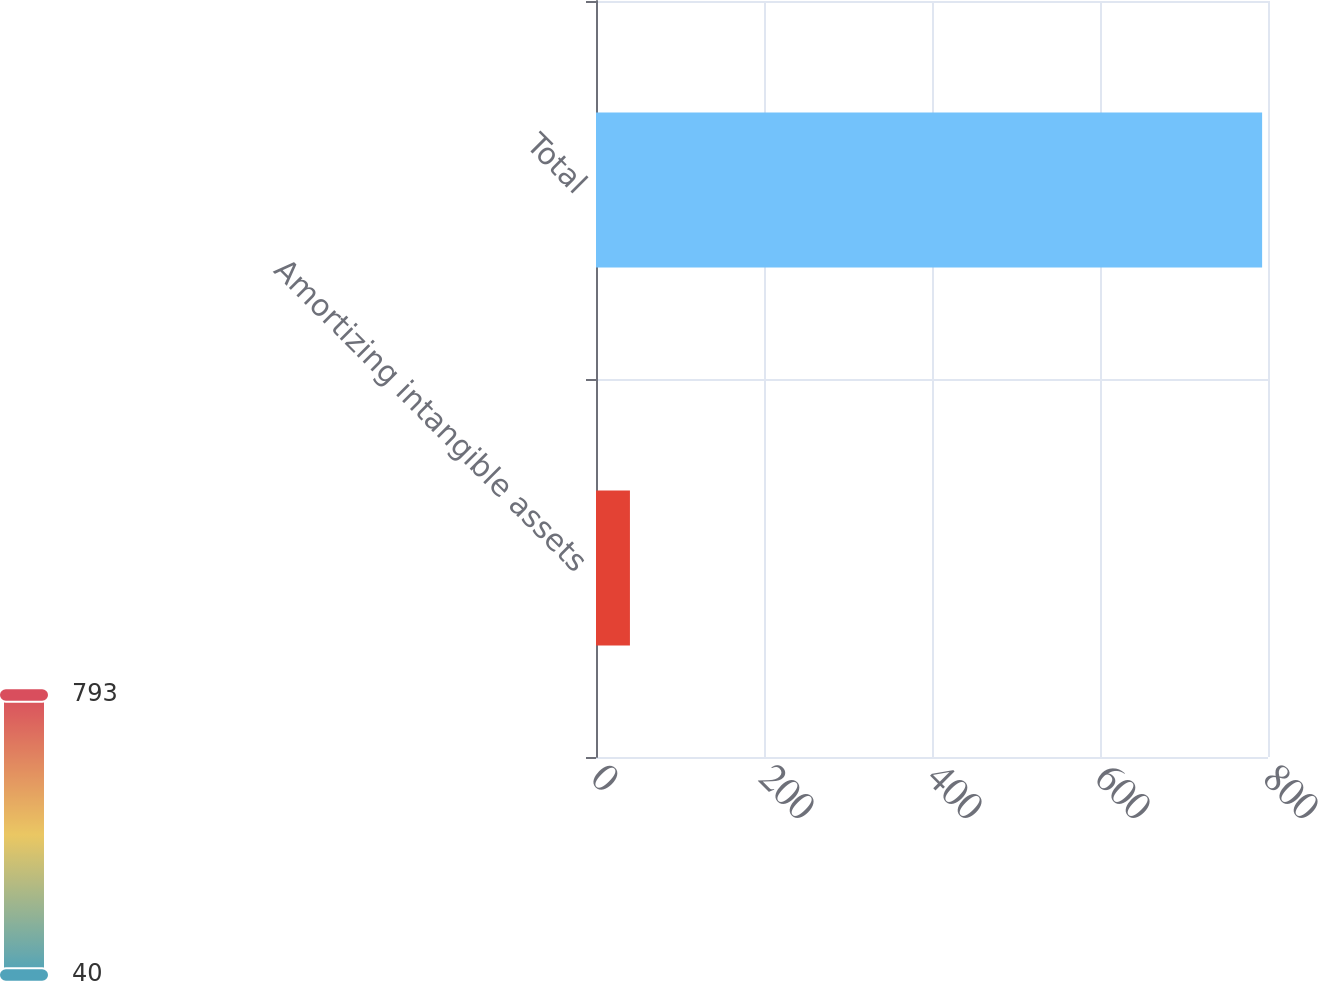<chart> <loc_0><loc_0><loc_500><loc_500><bar_chart><fcel>Amortizing intangible assets<fcel>Total<nl><fcel>40.4<fcel>793<nl></chart> 